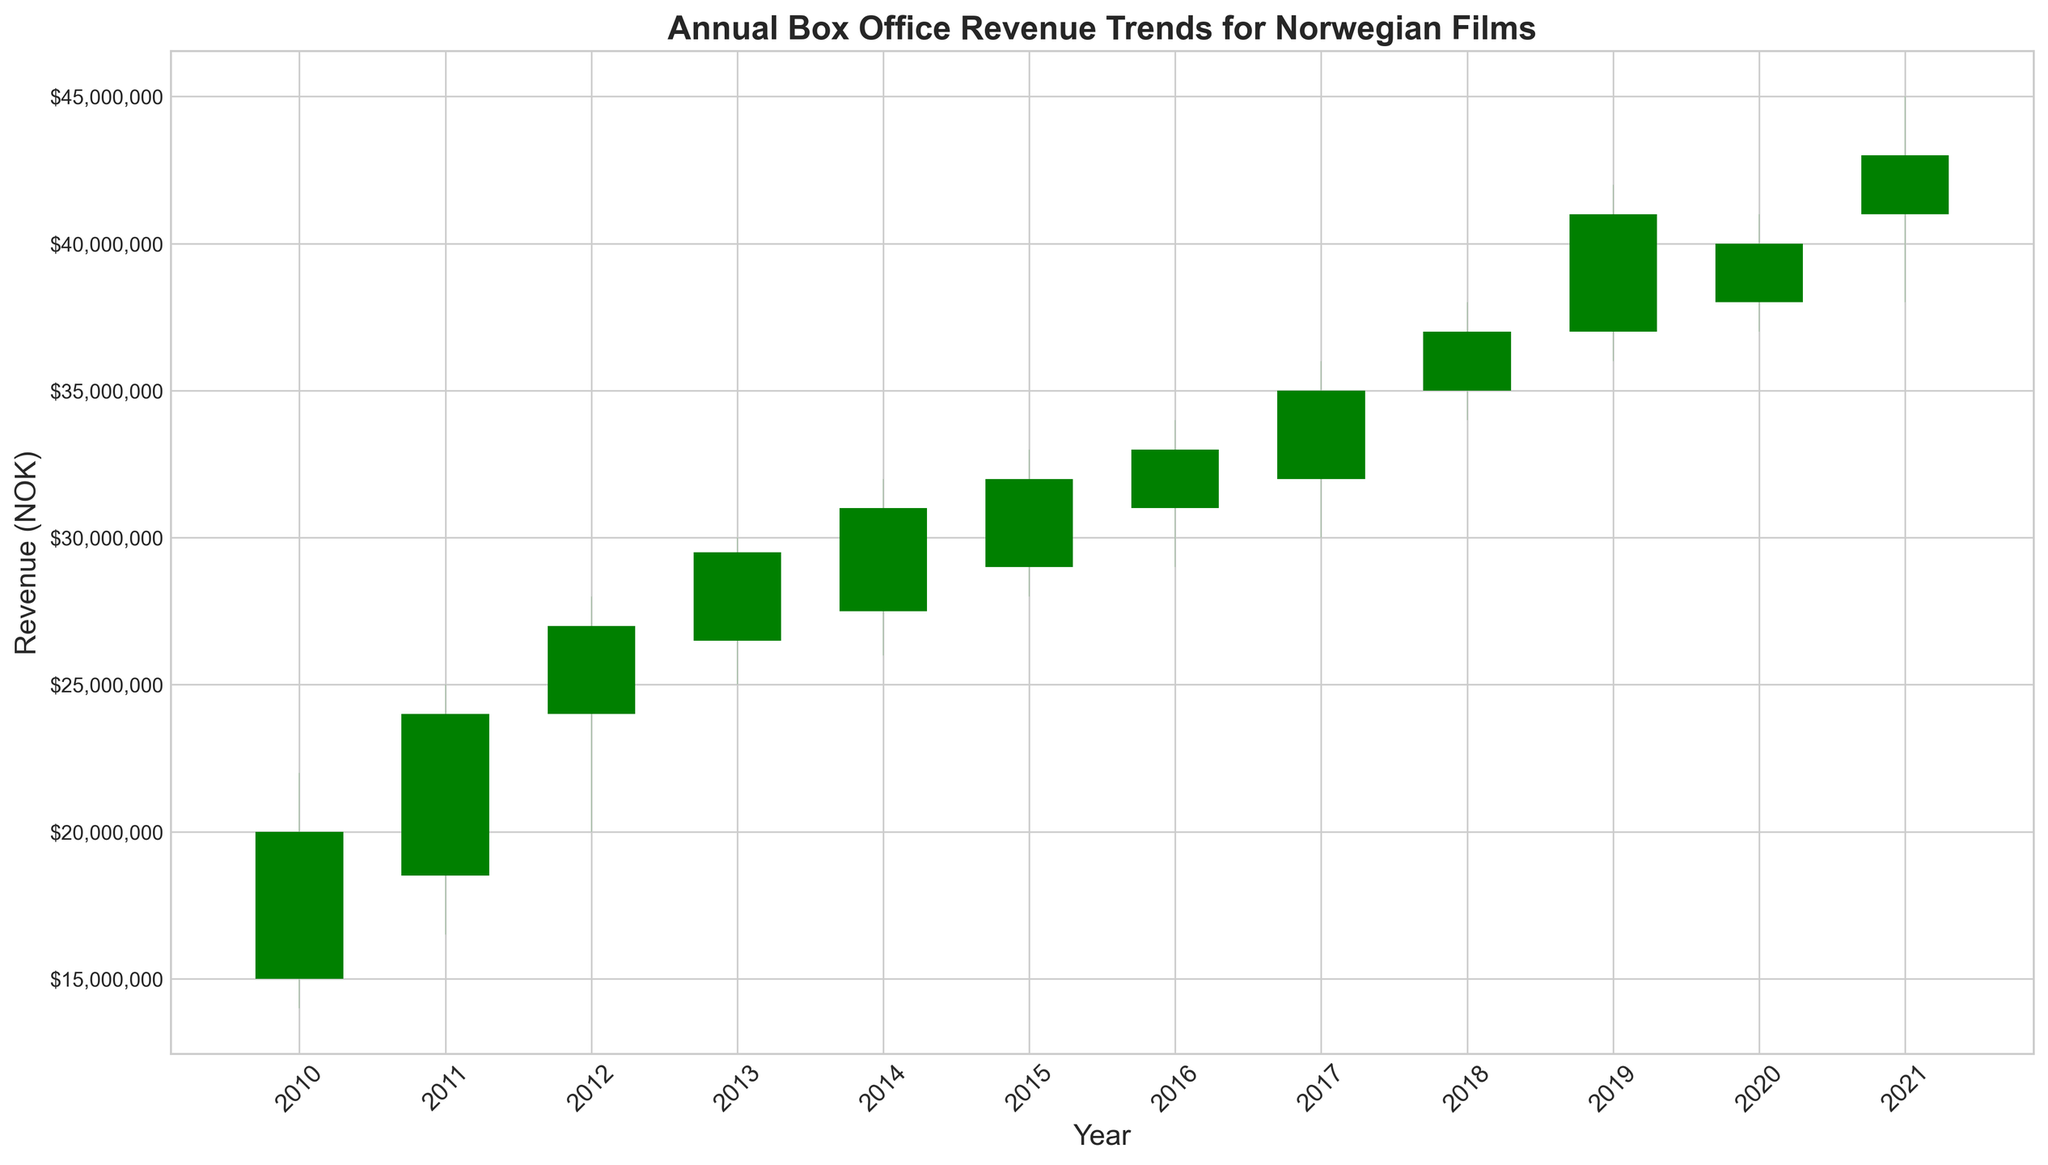What is the overall trend in the annual box office revenue for Norwegian films from 2010 to 2021? The candlestick chart generally shows an upward trend in the annual box office revenue. Starting from 2010, there are ups and downs, but the closing revenue consistently increases over the years, reaching its peak in 2021.
Answer: Upward trend In which year was the highest box office revenue recorded, and what was the value? Observing the candlestick chart, the highest box office revenue was recorded in 2019, with a High value of 42,000,000 NOK.
Answer: 2019, 42,000,000 NOK Compare the opening and closing revenues in 2018. Was there a gain or loss? In 2018, the opening revenue was 35,000,000 NOK, and the closing revenue was 37,000,000 NOK. Since the closing revenue is higher than the opening, there was a gain.
Answer: Gain Which year experienced the largest fluctuation in box office revenue and how can you tell? The year 2019 experienced the largest fluctuation. The difference between the High (42,000,000 NOK) and Low (36,000,000 NOK) values for that year is 6,000,000 NOK, which is the largest range observed in the chart.
Answer: 2019 What is the median closing revenue for the series from 2010 to 2021? First, list the closing revenues: [20,000,000, 24,000,000, 27,000,000, 29,500,000, 31,000,000, 32,000,000, 33,000,000, 35,000,000, 37,000,000, 41,000,000, 40,000,000, 43,000,000]. With 12 numbers, the median will be the average of the 6th and 7th values, which are 32,000,000 and 33,000,000. Thus, the median is (32,000,000 + 33,000,000) / 2 = 32,500,000 NOK.
Answer: 32,500,000 NOK In which year did the closing revenue first exceed 30,000,000 NOK? By examining the list of closing revenues over the years, the closing revenue first exceeded 30,000,000 NOK in 2014 when it reached 31,000,000 NOK.
Answer: 2014 What was the box office revenue range in 2020? The chart shows that in 2020, the Low was 37,000,000 NOK and the High was 41,000,000 NOK, making the range 41,000,000 - 37,000,000 = 4,000,000 NOK.
Answer: 4,000,000 NOK Compare the opening revenue of 2015 to the closing revenue of 2014. Were they the same? The opening revenue for 2015 was 29,000,000 NOK and the closing revenue for 2014 was 31,000,000 NOK. They were not the same; the closing revenue in 2014 was higher.
Answer: No Which color represents a gain in box office revenue within a year and what does that signify visually in terms of the bars' position? Green represents a gain in box office revenue within a year. Visually, this signifies that the closing value is higher than the opening value, so the top of the bar is higher than the bottom.
Answer: Green How many years showed a loss in annual box office revenue and which years were they? By identifying the red bars, we see that 2020 is the only year that showed a loss.
Answer: 1 (2020) 